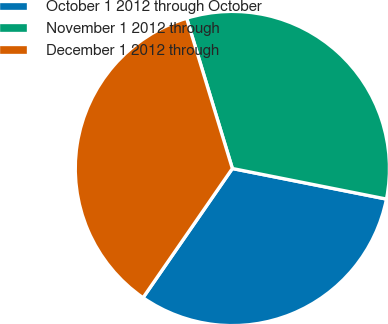<chart> <loc_0><loc_0><loc_500><loc_500><pie_chart><fcel>October 1 2012 through October<fcel>November 1 2012 through<fcel>December 1 2012 through<nl><fcel>31.51%<fcel>32.82%<fcel>35.67%<nl></chart> 